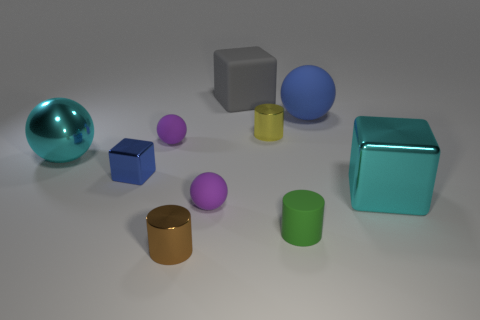There is a yellow metal object; is its shape the same as the green object that is behind the tiny brown cylinder?
Your answer should be compact. Yes. What number of rubber objects are either cyan things or purple blocks?
Keep it short and to the point. 0. Are there any rubber cylinders of the same color as the big shiny ball?
Your answer should be compact. No. Are there any cyan metal balls?
Provide a succinct answer. Yes. Is the shape of the yellow thing the same as the tiny green rubber thing?
Make the answer very short. Yes. How many large things are either brown matte objects or yellow shiny cylinders?
Offer a terse response. 0. What is the color of the big matte sphere?
Make the answer very short. Blue. What is the shape of the shiny thing in front of the tiny green cylinder that is in front of the blue ball?
Your answer should be very brief. Cylinder. Are there any cyan cubes that have the same material as the small blue cube?
Keep it short and to the point. Yes. Does the purple rubber thing that is behind the cyan sphere have the same size as the small yellow cylinder?
Your answer should be compact. Yes. 